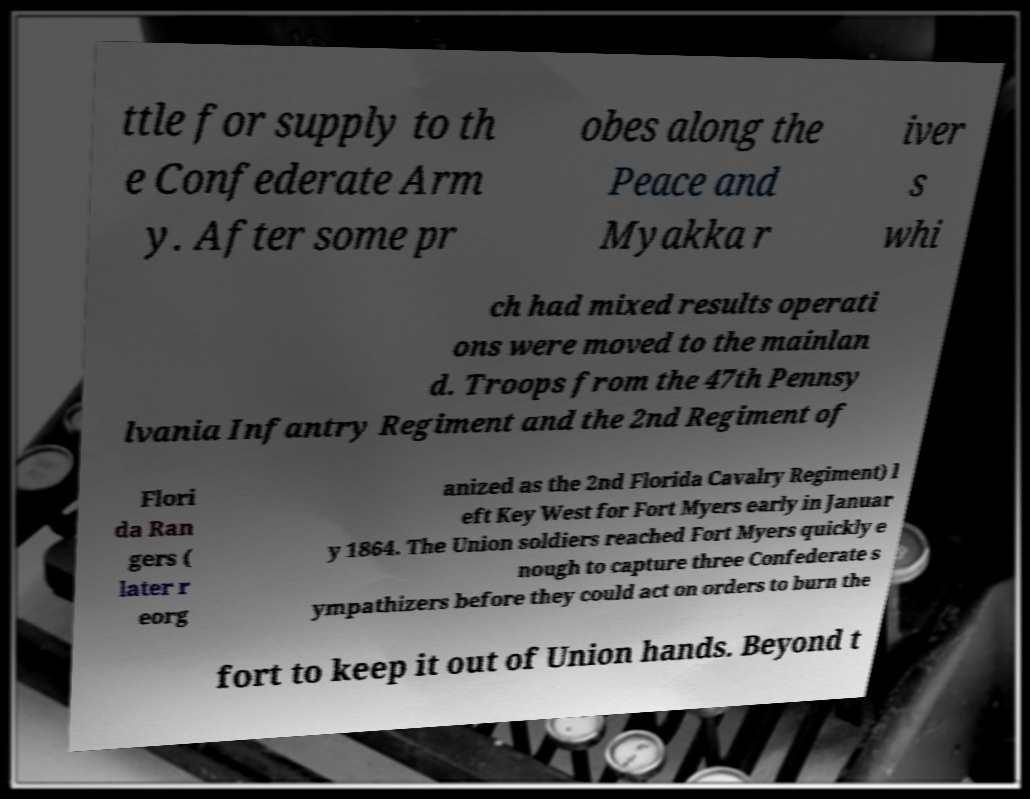Please read and relay the text visible in this image. What does it say? ttle for supply to th e Confederate Arm y. After some pr obes along the Peace and Myakka r iver s whi ch had mixed results operati ons were moved to the mainlan d. Troops from the 47th Pennsy lvania Infantry Regiment and the 2nd Regiment of Flori da Ran gers ( later r eorg anized as the 2nd Florida Cavalry Regiment) l eft Key West for Fort Myers early in Januar y 1864. The Union soldiers reached Fort Myers quickly e nough to capture three Confederate s ympathizers before they could act on orders to burn the fort to keep it out of Union hands. Beyond t 